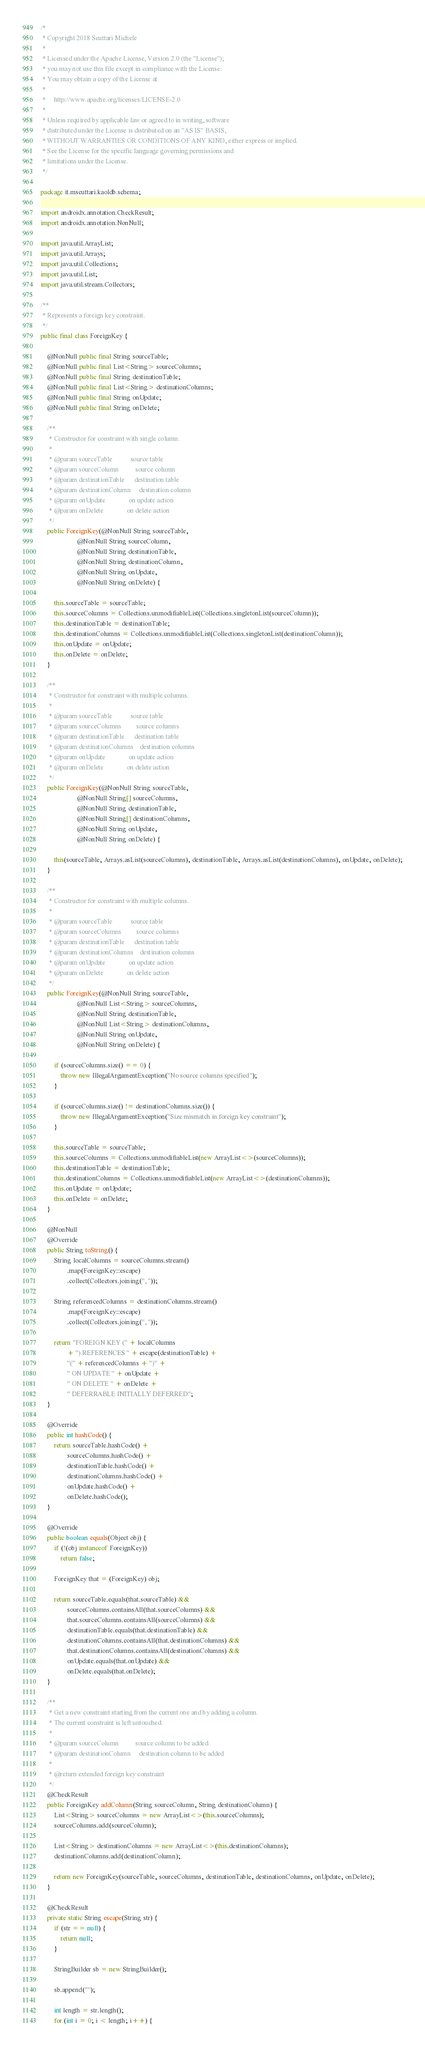<code> <loc_0><loc_0><loc_500><loc_500><_Java_>/*
 * Copyright 2018 Scuttari Michele
 *
 * Licensed under the Apache License, Version 2.0 (the "License");
 * you may not use this file except in compliance with the License.
 * You may obtain a copy of the License at
 *
 *     http://www.apache.org/licenses/LICENSE-2.0
 *
 * Unless required by applicable law or agreed to in writing, software
 * distributed under the License is distributed on an "AS IS" BASIS,
 * WITHOUT WARRANTIES OR CONDITIONS OF ANY KIND, either express or implied.
 * See the License for the specific language governing permissions and
 * limitations under the License.
 */

package it.mscuttari.kaoldb.schema;

import androidx.annotation.CheckResult;
import androidx.annotation.NonNull;

import java.util.ArrayList;
import java.util.Arrays;
import java.util.Collections;
import java.util.List;
import java.util.stream.Collectors;

/**
 * Represents a foreign key constraint.
 */
public final class ForeignKey {

    @NonNull public final String sourceTable;
    @NonNull public final List<String> sourceColumns;
    @NonNull public final String destinationTable;
    @NonNull public final List<String> destinationColumns;
    @NonNull public final String onUpdate;
    @NonNull public final String onDelete;

    /**
     * Constructor for constraint with single column.
     *
     * @param sourceTable           source table
     * @param sourceColumn          source column
     * @param destinationTable      destination table
     * @param destinationColumn     destination column
     * @param onUpdate              on update action
     * @param onDelete              on delete action
     */
    public ForeignKey(@NonNull String sourceTable,
                      @NonNull String sourceColumn,
                      @NonNull String destinationTable,
                      @NonNull String destinationColumn,
                      @NonNull String onUpdate,
                      @NonNull String onDelete) {

        this.sourceTable = sourceTable;
        this.sourceColumns = Collections.unmodifiableList(Collections.singletonList(sourceColumn));
        this.destinationTable = destinationTable;
        this.destinationColumns = Collections.unmodifiableList(Collections.singletonList(destinationColumn));
        this.onUpdate = onUpdate;
        this.onDelete = onDelete;
    }

    /**
     * Constructor for constraint with multiple columns.
     *
     * @param sourceTable           source table
     * @param sourceColumns         source columns
     * @param destinationTable      destination table
     * @param destinationColumns    destination columns
     * @param onUpdate              on update action
     * @param onDelete              on delete action
     */
    public ForeignKey(@NonNull String sourceTable,
                      @NonNull String[] sourceColumns,
                      @NonNull String destinationTable,
                      @NonNull String[] destinationColumns,
                      @NonNull String onUpdate,
                      @NonNull String onDelete) {

        this(sourceTable, Arrays.asList(sourceColumns), destinationTable, Arrays.asList(destinationColumns), onUpdate, onDelete);
    }

    /**
     * Constructor for constraint with multiple columns.
     *
     * @param sourceTable           source table
     * @param sourceColumns         source columns
     * @param destinationTable      destination table
     * @param destinationColumns    destination columns
     * @param onUpdate              on update action
     * @param onDelete              on delete action
     */
    public ForeignKey(@NonNull String sourceTable,
                      @NonNull List<String> sourceColumns,
                      @NonNull String destinationTable,
                      @NonNull List<String> destinationColumns,
                      @NonNull String onUpdate,
                      @NonNull String onDelete) {

        if (sourceColumns.size() == 0) {
            throw new IllegalArgumentException("No source columns specified");
        }

        if (sourceColumns.size() != destinationColumns.size()) {
            throw new IllegalArgumentException("Size mismatch in foreign key constraint");
        }

        this.sourceTable = sourceTable;
        this.sourceColumns = Collections.unmodifiableList(new ArrayList<>(sourceColumns));
        this.destinationTable = destinationTable;
        this.destinationColumns = Collections.unmodifiableList(new ArrayList<>(destinationColumns));
        this.onUpdate = onUpdate;
        this.onDelete = onDelete;
    }

    @NonNull
    @Override
    public String toString() {
        String localColumns = sourceColumns.stream()
                .map(ForeignKey::escape)
                .collect(Collectors.joining(", "));

        String referencedColumns = destinationColumns.stream()
                .map(ForeignKey::escape)
                .collect(Collectors.joining(", "));

        return "FOREIGN KEY (" + localColumns
                + ") REFERENCES " + escape(destinationTable) +
                "(" + referencedColumns + ")" +
                " ON UPDATE " + onUpdate +
                " ON DELETE " + onDelete +
                " DEFERRABLE INITIALLY DEFERRED";
    }

    @Override
    public int hashCode() {
        return sourceTable.hashCode() +
                sourceColumns.hashCode() +
                destinationTable.hashCode() +
                destinationColumns.hashCode() +
                onUpdate.hashCode() +
                onDelete.hashCode();
    }

    @Override
    public boolean equals(Object obj) {
        if (!(obj instanceof ForeignKey))
            return false;

        ForeignKey that = (ForeignKey) obj;

        return sourceTable.equals(that.sourceTable) &&
                sourceColumns.containsAll(that.sourceColumns) &&
                that.sourceColumns.containsAll(sourceColumns) &&
                destinationTable.equals(that.destinationTable) &&
                destinationColumns.containsAll(that.destinationColumns) &&
                that.destinationColumns.containsAll(destinationColumns) &&
                onUpdate.equals(that.onUpdate) &&
                onDelete.equals(that.onDelete);
    }

    /**
     * Get a new constraint starting from the current one and by adding a column.
     * The current constraint is left untouched.
     *
     * @param sourceColumn          source column to be added
     * @param destinationColumn     destination column to be added
     *
     * @return extended foreign key constraint
     */
    @CheckResult
    public ForeignKey addColumn(String sourceColumn, String destinationColumn) {
        List<String> sourceColumns = new ArrayList<>(this.sourceColumns);
        sourceColumns.add(sourceColumn);

        List<String> destinationColumns = new ArrayList<>(this.destinationColumns);
        destinationColumns.add(destinationColumn);

        return new ForeignKey(sourceTable, sourceColumns, destinationTable, destinationColumns, onUpdate, onDelete);
    }

    @CheckResult
    private static String escape(String str) {
        if (str == null) {
            return null;
        }

        StringBuilder sb = new StringBuilder();

        sb.append('"');

        int length = str.length();
        for (int i = 0; i < length; i++) {</code> 